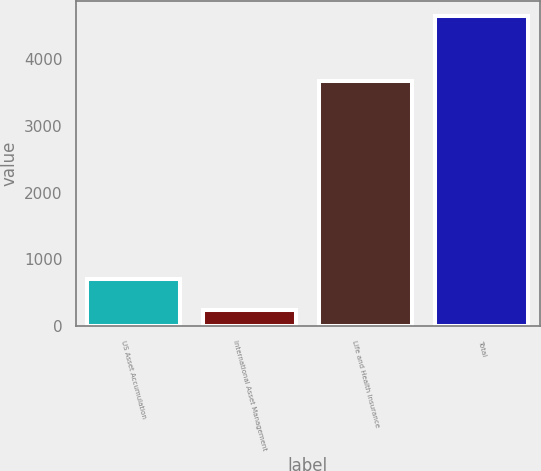Convert chart. <chart><loc_0><loc_0><loc_500><loc_500><bar_chart><fcel>US Asset Accumulation<fcel>International Asset Management<fcel>Life and Health Insurance<fcel>Total<nl><fcel>710.8<fcel>246.4<fcel>3671.6<fcel>4634.1<nl></chart> 